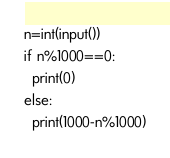<code> <loc_0><loc_0><loc_500><loc_500><_Python_>n=int(input())
if n%1000==0:
  print(0)
else:
  print(1000-n%1000)</code> 